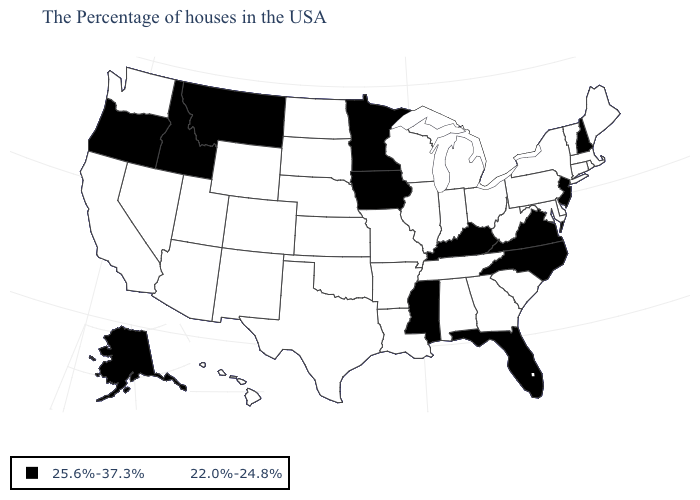Does Colorado have the same value as Ohio?
Be succinct. Yes. What is the value of Alaska?
Short answer required. 25.6%-37.3%. Name the states that have a value in the range 25.6%-37.3%?
Give a very brief answer. New Hampshire, New Jersey, Virginia, North Carolina, Florida, Kentucky, Mississippi, Minnesota, Iowa, Montana, Idaho, Oregon, Alaska. What is the value of Arizona?
Keep it brief. 22.0%-24.8%. Which states hav the highest value in the South?
Short answer required. Virginia, North Carolina, Florida, Kentucky, Mississippi. Is the legend a continuous bar?
Keep it brief. No. What is the highest value in the USA?
Keep it brief. 25.6%-37.3%. What is the value of Vermont?
Quick response, please. 22.0%-24.8%. What is the highest value in the USA?
Give a very brief answer. 25.6%-37.3%. What is the value of Iowa?
Give a very brief answer. 25.6%-37.3%. What is the value of California?
Give a very brief answer. 22.0%-24.8%. Which states have the highest value in the USA?
Keep it brief. New Hampshire, New Jersey, Virginia, North Carolina, Florida, Kentucky, Mississippi, Minnesota, Iowa, Montana, Idaho, Oregon, Alaska. Does Louisiana have the highest value in the USA?
Keep it brief. No. What is the lowest value in the USA?
Write a very short answer. 22.0%-24.8%. 